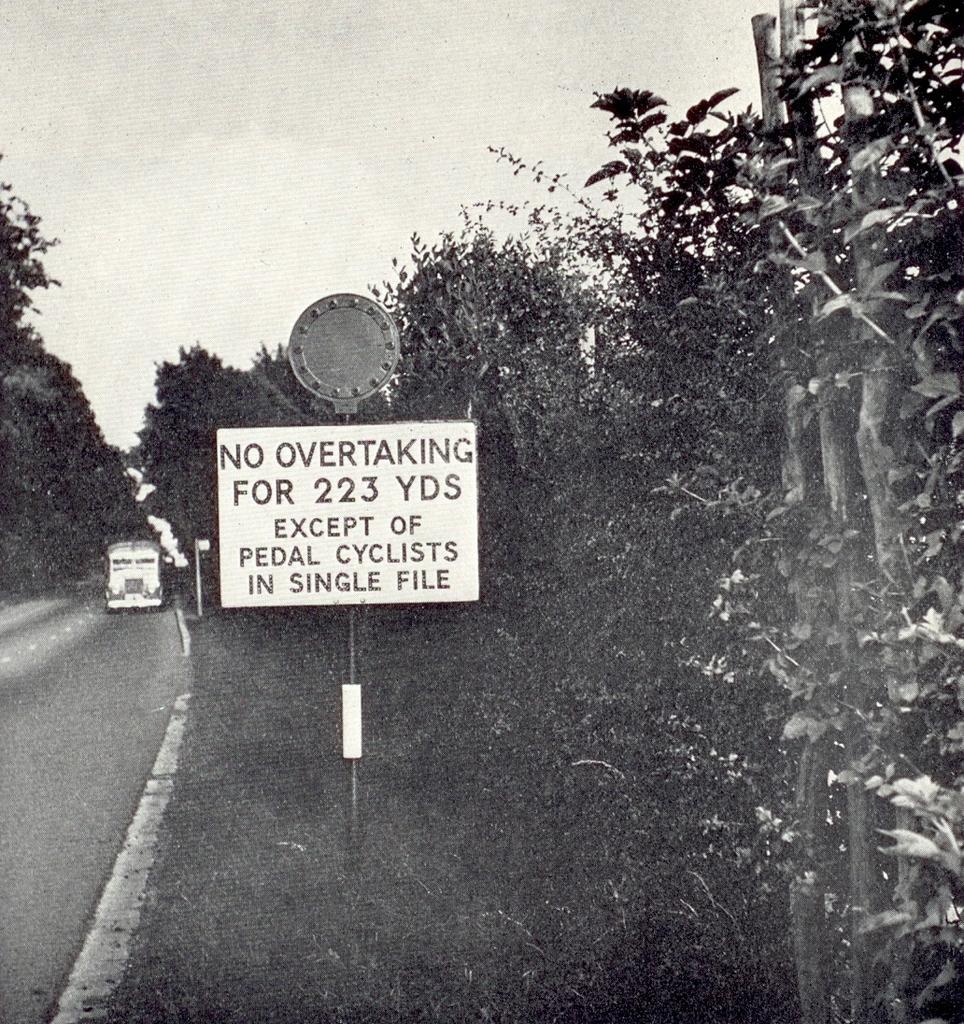Please provide a concise description of this image. It is a black and white picture. On the left side of the image there is a vehicle, road, trees, boards and poles. On the right side of the image there are trees. In the background of the image there is the sky. 